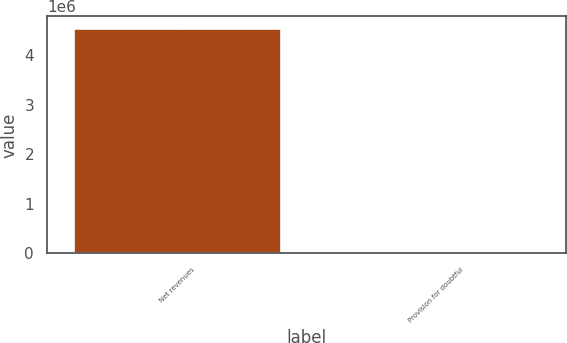Convert chart. <chart><loc_0><loc_0><loc_500><loc_500><bar_chart><fcel>Net revenues<fcel>Provision for doubtful<nl><fcel>4.5524e+06<fcel>1.97<nl></chart> 